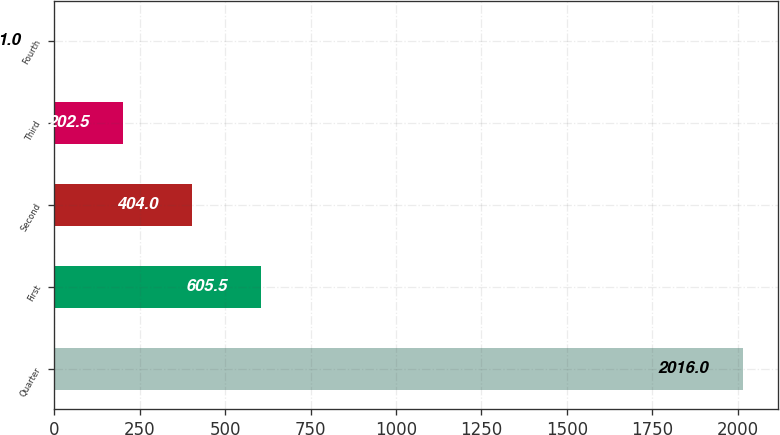Convert chart. <chart><loc_0><loc_0><loc_500><loc_500><bar_chart><fcel>Quarter<fcel>First<fcel>Second<fcel>Third<fcel>Fourth<nl><fcel>2016<fcel>605.5<fcel>404<fcel>202.5<fcel>1<nl></chart> 